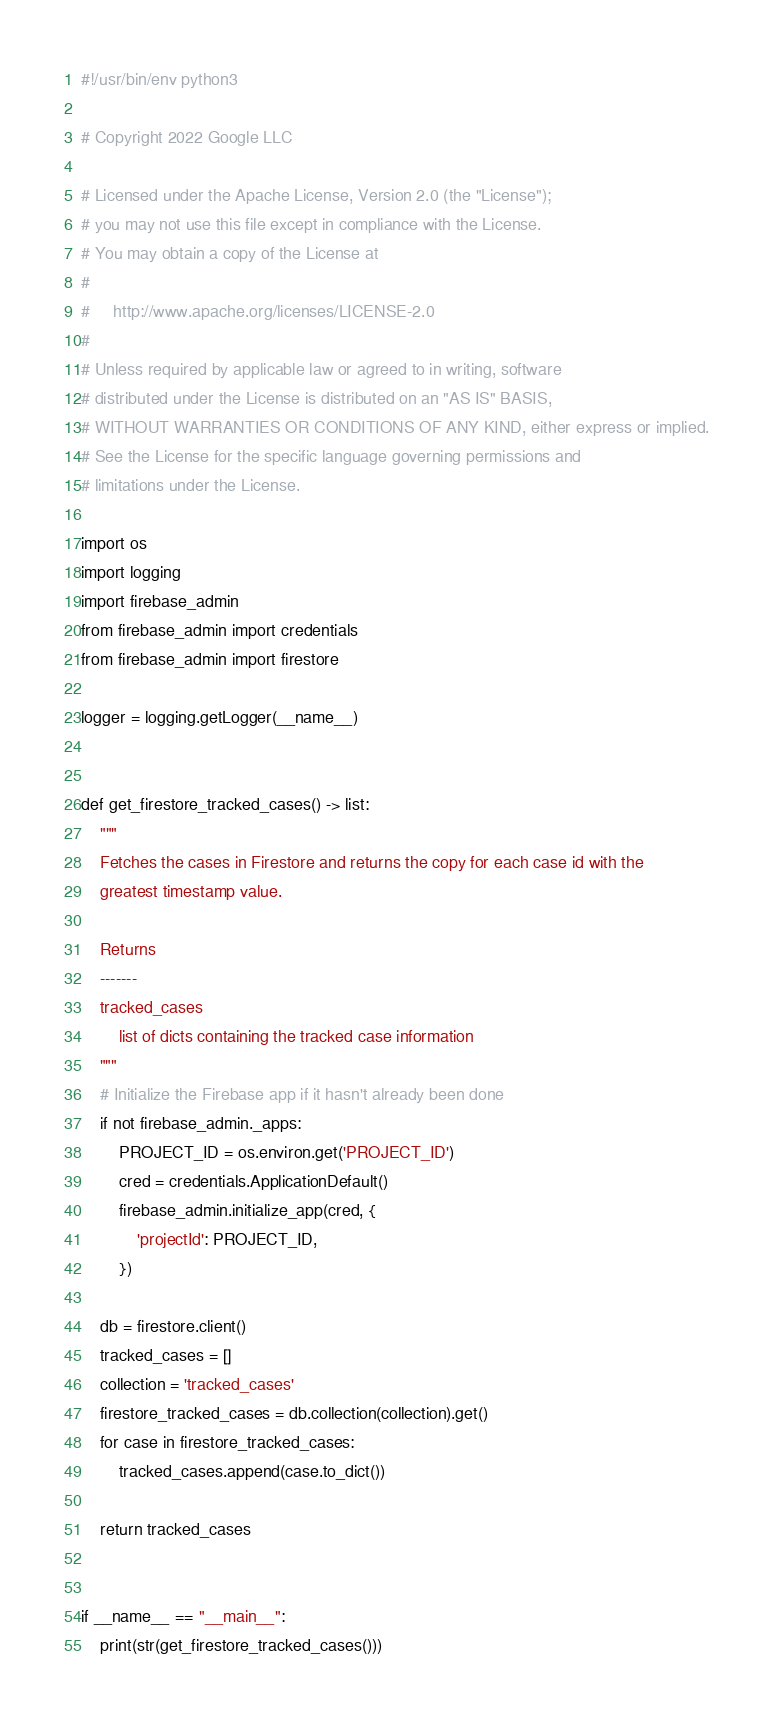Convert code to text. <code><loc_0><loc_0><loc_500><loc_500><_Python_>#!/usr/bin/env python3

# Copyright 2022 Google LLC

# Licensed under the Apache License, Version 2.0 (the "License");
# you may not use this file except in compliance with the License.
# You may obtain a copy of the License at
#
#     http://www.apache.org/licenses/LICENSE-2.0
#
# Unless required by applicable law or agreed to in writing, software
# distributed under the License is distributed on an "AS IS" BASIS,
# WITHOUT WARRANTIES OR CONDITIONS OF ANY KIND, either express or implied.
# See the License for the specific language governing permissions and
# limitations under the License.

import os
import logging
import firebase_admin
from firebase_admin import credentials
from firebase_admin import firestore

logger = logging.getLogger(__name__)


def get_firestore_tracked_cases() -> list:
    """
    Fetches the cases in Firestore and returns the copy for each case id with the
    greatest timestamp value.

    Returns
    -------
    tracked_cases
        list of dicts containing the tracked case information
    """
    # Initialize the Firebase app if it hasn't already been done
    if not firebase_admin._apps:
        PROJECT_ID = os.environ.get('PROJECT_ID')
        cred = credentials.ApplicationDefault()
        firebase_admin.initialize_app(cred, {
            'projectId': PROJECT_ID,
        })

    db = firestore.client()
    tracked_cases = []
    collection = 'tracked_cases'
    firestore_tracked_cases = db.collection(collection).get()
    for case in firestore_tracked_cases:
        tracked_cases.append(case.to_dict())

    return tracked_cases


if __name__ == "__main__":
    print(str(get_firestore_tracked_cases()))
</code> 